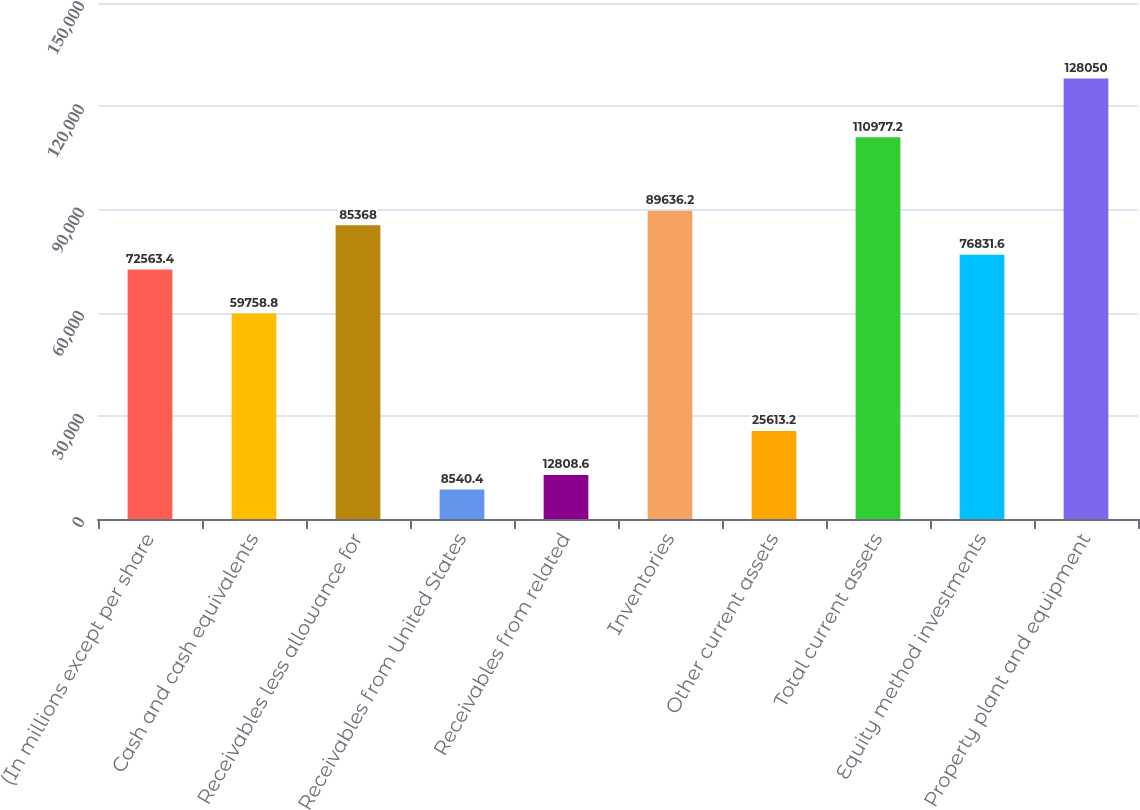<chart> <loc_0><loc_0><loc_500><loc_500><bar_chart><fcel>(In millions except per share<fcel>Cash and cash equivalents<fcel>Receivables less allowance for<fcel>Receivables from United States<fcel>Receivables from related<fcel>Inventories<fcel>Other current assets<fcel>Total current assets<fcel>Equity method investments<fcel>Property plant and equipment<nl><fcel>72563.4<fcel>59758.8<fcel>85368<fcel>8540.4<fcel>12808.6<fcel>89636.2<fcel>25613.2<fcel>110977<fcel>76831.6<fcel>128050<nl></chart> 